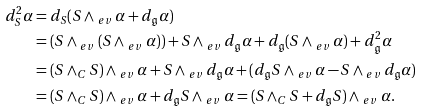<formula> <loc_0><loc_0><loc_500><loc_500>d ^ { 2 } _ { S } \alpha & = d _ { S } ( S \wedge _ { \ e v } \alpha + d _ { \mathfrak { g } } \alpha ) \\ & = ( S \wedge _ { \ e v } ( S \wedge _ { \ e v } \alpha ) ) + S \wedge _ { \ e v } d _ { \mathfrak { g } } \alpha + d _ { \mathfrak { g } } ( S \wedge _ { \ e v } \alpha ) + d ^ { 2 } _ { \mathfrak { g } } \alpha \\ & = ( S \wedge _ { C } S ) \wedge _ { \ e v } \alpha + S \wedge _ { \ e v } d _ { \mathfrak { g } } \alpha + ( d _ { \mathfrak { g } } S \wedge _ { \ e v } \alpha - S \wedge _ { \ e v } d _ { \mathfrak { g } } \alpha ) \\ & = ( S \wedge _ { C } S ) \wedge _ { \ e v } \alpha + d _ { \mathfrak { g } } S \wedge _ { \ e v } \alpha = ( S \wedge _ { C } S + d _ { \mathfrak { g } } S ) \wedge _ { \ e v } \alpha .</formula> 